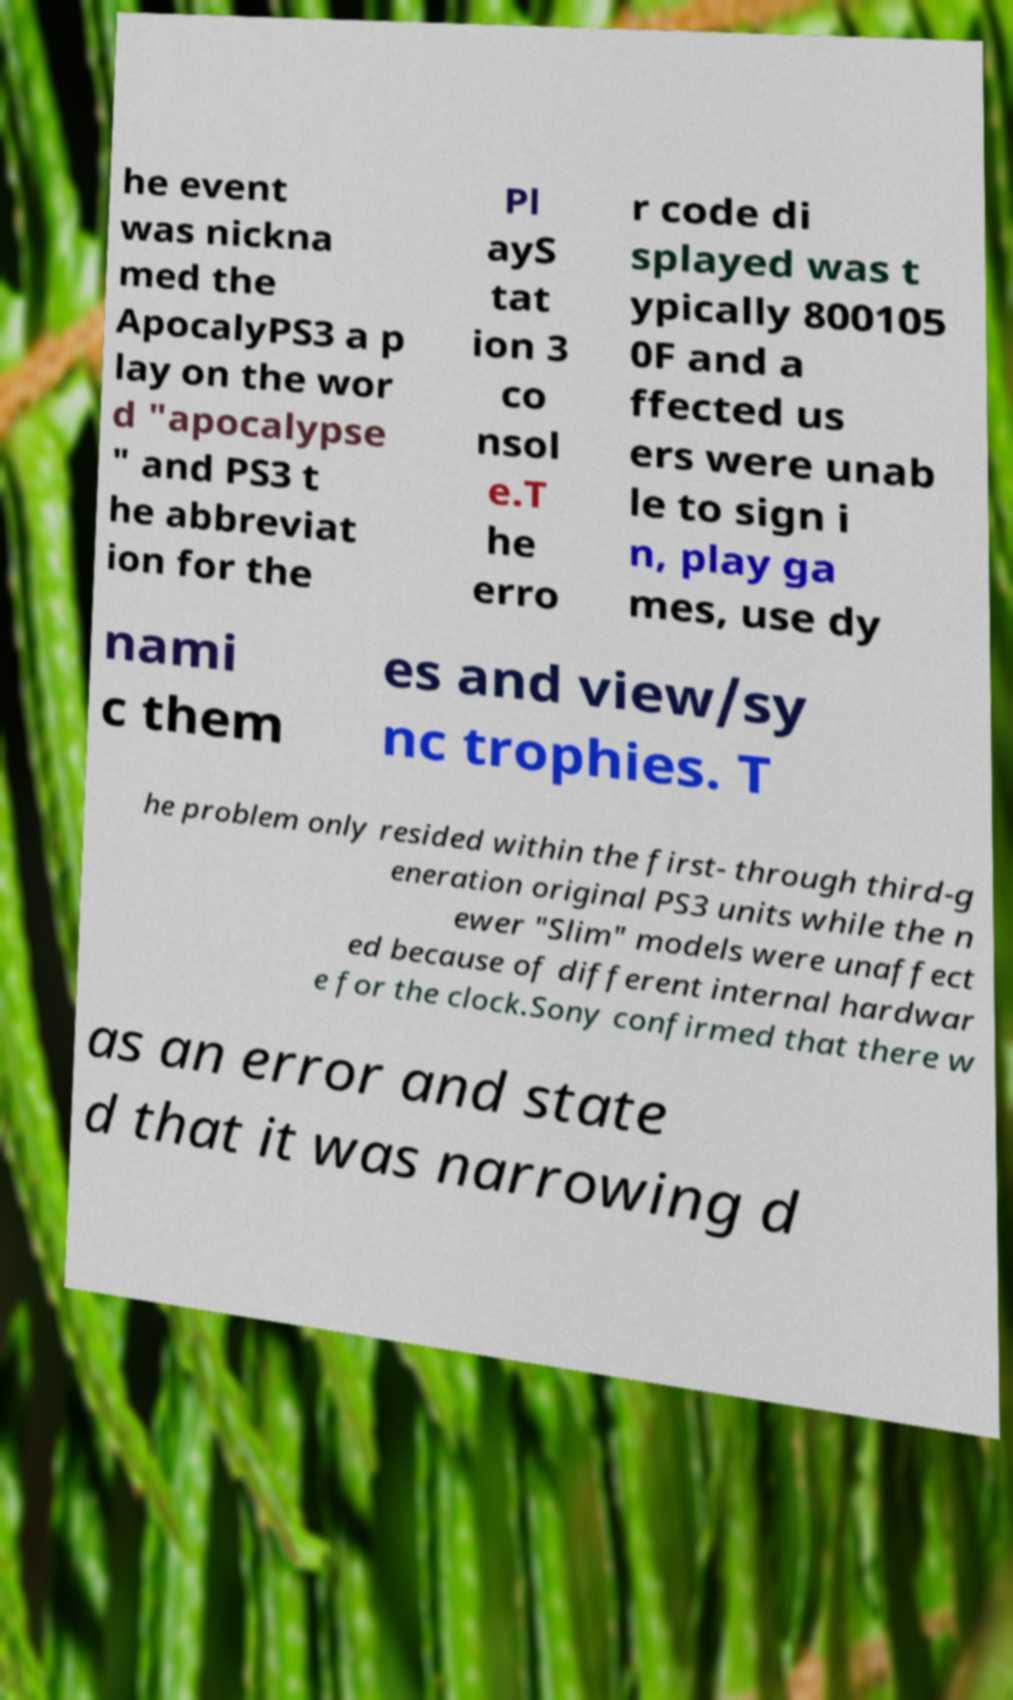Could you assist in decoding the text presented in this image and type it out clearly? he event was nickna med the ApocalyPS3 a p lay on the wor d "apocalypse " and PS3 t he abbreviat ion for the Pl ayS tat ion 3 co nsol e.T he erro r code di splayed was t ypically 800105 0F and a ffected us ers were unab le to sign i n, play ga mes, use dy nami c them es and view/sy nc trophies. T he problem only resided within the first- through third-g eneration original PS3 units while the n ewer "Slim" models were unaffect ed because of different internal hardwar e for the clock.Sony confirmed that there w as an error and state d that it was narrowing d 